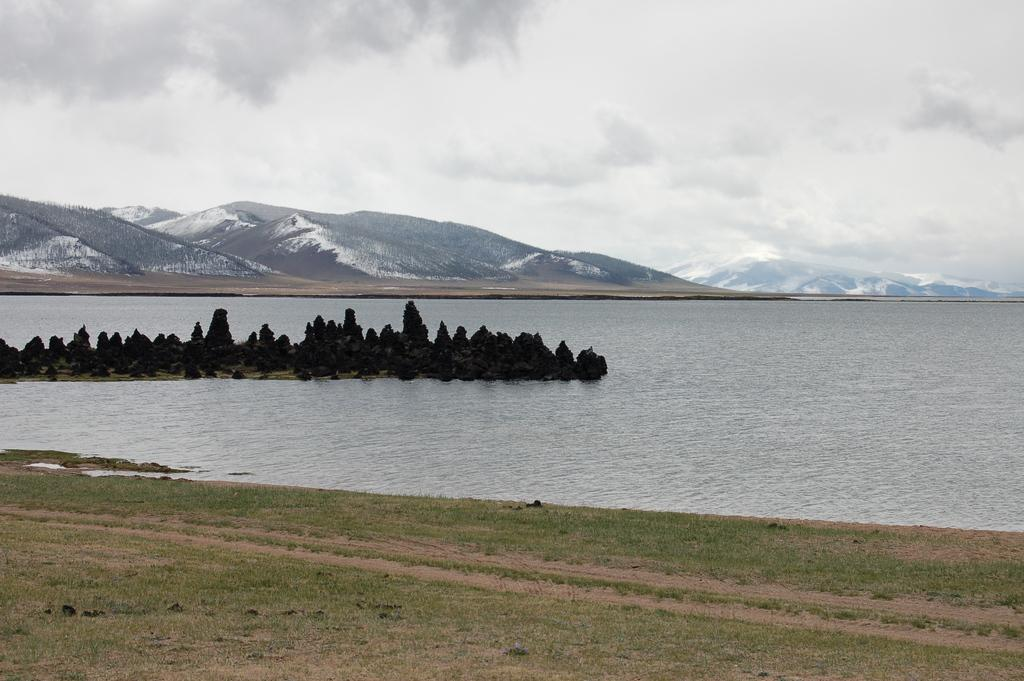What type of natural feature is present in the image? There is a lake in the image. What can be seen in the middle of the lake? There are trees in the middle of the lake. What is visible in the background of the image? There are mountains visible at the back of the image. What type of brush can be seen in the image? There is no brush present in the image. Is there a hole in the lake in the image? There is no hole visible in the lake in the image. 